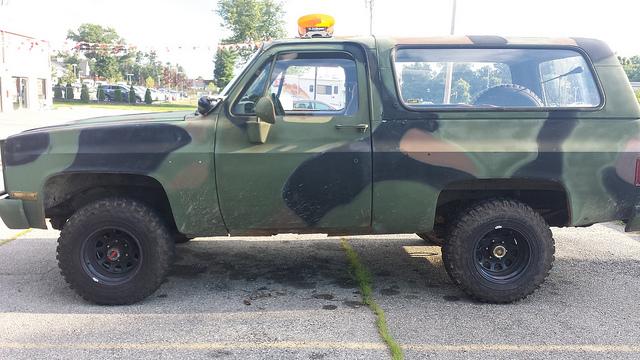Is there a banner in the background?
Answer briefly. Yes. What type of moving vehicle is this?
Write a very short answer. Truck. What color is the light on the bar on top?
Quick response, please. Yellow. 